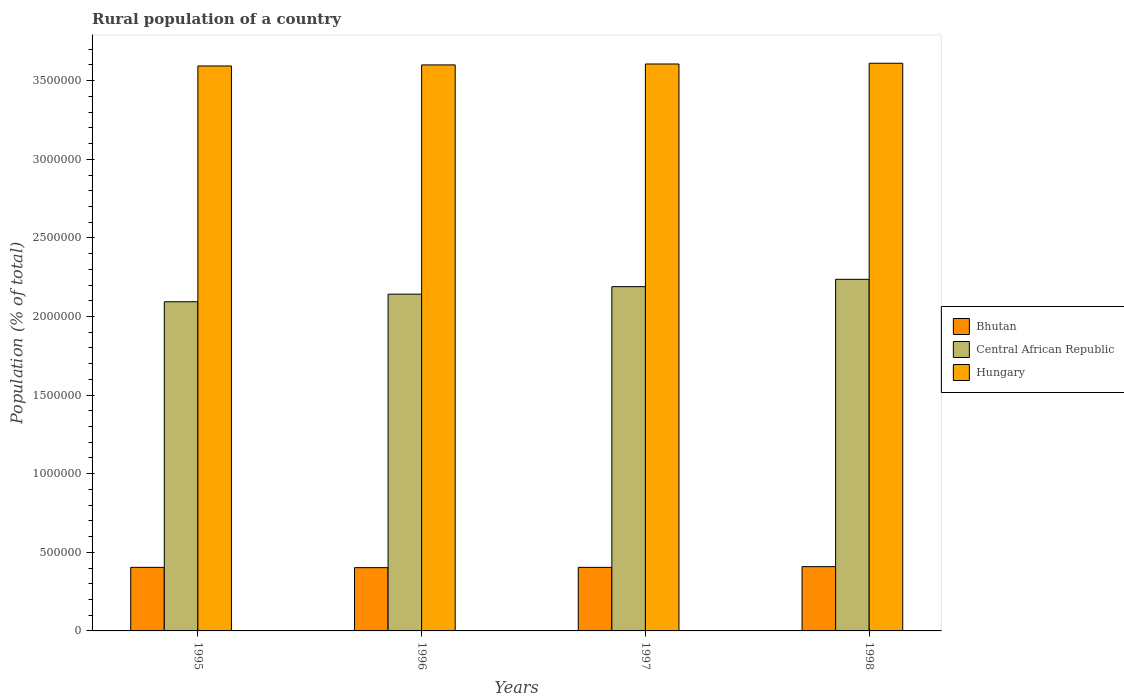How many bars are there on the 3rd tick from the left?
Provide a succinct answer. 3. How many bars are there on the 3rd tick from the right?
Offer a very short reply. 3. What is the label of the 3rd group of bars from the left?
Make the answer very short. 1997. In how many cases, is the number of bars for a given year not equal to the number of legend labels?
Give a very brief answer. 0. What is the rural population in Bhutan in 1997?
Your answer should be compact. 4.04e+05. Across all years, what is the maximum rural population in Hungary?
Your response must be concise. 3.61e+06. Across all years, what is the minimum rural population in Bhutan?
Offer a very short reply. 4.02e+05. In which year was the rural population in Central African Republic maximum?
Your answer should be very brief. 1998. In which year was the rural population in Hungary minimum?
Offer a terse response. 1995. What is the total rural population in Central African Republic in the graph?
Your answer should be compact. 8.66e+06. What is the difference between the rural population in Central African Republic in 1995 and that in 1998?
Keep it short and to the point. -1.43e+05. What is the difference between the rural population in Central African Republic in 1998 and the rural population in Bhutan in 1995?
Offer a terse response. 1.83e+06. What is the average rural population in Hungary per year?
Offer a very short reply. 3.60e+06. In the year 1998, what is the difference between the rural population in Hungary and rural population in Central African Republic?
Offer a very short reply. 1.37e+06. What is the ratio of the rural population in Bhutan in 1996 to that in 1997?
Give a very brief answer. 1. Is the rural population in Hungary in 1996 less than that in 1997?
Keep it short and to the point. Yes. What is the difference between the highest and the second highest rural population in Hungary?
Your response must be concise. 4657. What is the difference between the highest and the lowest rural population in Hungary?
Offer a very short reply. 1.73e+04. In how many years, is the rural population in Central African Republic greater than the average rural population in Central African Republic taken over all years?
Give a very brief answer. 2. Is the sum of the rural population in Hungary in 1995 and 1997 greater than the maximum rural population in Central African Republic across all years?
Make the answer very short. Yes. What does the 2nd bar from the left in 1996 represents?
Your answer should be compact. Central African Republic. What does the 2nd bar from the right in 1995 represents?
Offer a terse response. Central African Republic. How many bars are there?
Make the answer very short. 12. Are all the bars in the graph horizontal?
Offer a terse response. No. How many years are there in the graph?
Your response must be concise. 4. Does the graph contain any zero values?
Offer a very short reply. No. Does the graph contain grids?
Keep it short and to the point. No. How many legend labels are there?
Your response must be concise. 3. How are the legend labels stacked?
Your answer should be very brief. Vertical. What is the title of the graph?
Provide a short and direct response. Rural population of a country. What is the label or title of the Y-axis?
Make the answer very short. Population (% of total). What is the Population (% of total) of Bhutan in 1995?
Make the answer very short. 4.04e+05. What is the Population (% of total) in Central African Republic in 1995?
Your answer should be very brief. 2.09e+06. What is the Population (% of total) of Hungary in 1995?
Ensure brevity in your answer.  3.59e+06. What is the Population (% of total) in Bhutan in 1996?
Keep it short and to the point. 4.02e+05. What is the Population (% of total) in Central African Republic in 1996?
Ensure brevity in your answer.  2.14e+06. What is the Population (% of total) in Hungary in 1996?
Ensure brevity in your answer.  3.60e+06. What is the Population (% of total) in Bhutan in 1997?
Offer a very short reply. 4.04e+05. What is the Population (% of total) in Central African Republic in 1997?
Make the answer very short. 2.19e+06. What is the Population (% of total) of Hungary in 1997?
Offer a terse response. 3.61e+06. What is the Population (% of total) in Bhutan in 1998?
Offer a very short reply. 4.09e+05. What is the Population (% of total) of Central African Republic in 1998?
Offer a very short reply. 2.24e+06. What is the Population (% of total) in Hungary in 1998?
Make the answer very short. 3.61e+06. Across all years, what is the maximum Population (% of total) in Bhutan?
Provide a succinct answer. 4.09e+05. Across all years, what is the maximum Population (% of total) in Central African Republic?
Provide a short and direct response. 2.24e+06. Across all years, what is the maximum Population (% of total) of Hungary?
Your answer should be compact. 3.61e+06. Across all years, what is the minimum Population (% of total) in Bhutan?
Your answer should be very brief. 4.02e+05. Across all years, what is the minimum Population (% of total) of Central African Republic?
Offer a very short reply. 2.09e+06. Across all years, what is the minimum Population (% of total) of Hungary?
Your answer should be very brief. 3.59e+06. What is the total Population (% of total) in Bhutan in the graph?
Your answer should be very brief. 1.62e+06. What is the total Population (% of total) in Central African Republic in the graph?
Your response must be concise. 8.66e+06. What is the total Population (% of total) of Hungary in the graph?
Give a very brief answer. 1.44e+07. What is the difference between the Population (% of total) of Bhutan in 1995 and that in 1996?
Keep it short and to the point. 1944. What is the difference between the Population (% of total) in Central African Republic in 1995 and that in 1996?
Provide a short and direct response. -4.83e+04. What is the difference between the Population (% of total) in Hungary in 1995 and that in 1996?
Provide a succinct answer. -6825. What is the difference between the Population (% of total) in Bhutan in 1995 and that in 1997?
Provide a succinct answer. 159. What is the difference between the Population (% of total) of Central African Republic in 1995 and that in 1997?
Give a very brief answer. -9.60e+04. What is the difference between the Population (% of total) of Hungary in 1995 and that in 1997?
Your response must be concise. -1.26e+04. What is the difference between the Population (% of total) in Bhutan in 1995 and that in 1998?
Make the answer very short. -4403. What is the difference between the Population (% of total) of Central African Republic in 1995 and that in 1998?
Your answer should be very brief. -1.43e+05. What is the difference between the Population (% of total) of Hungary in 1995 and that in 1998?
Your answer should be compact. -1.73e+04. What is the difference between the Population (% of total) in Bhutan in 1996 and that in 1997?
Ensure brevity in your answer.  -1785. What is the difference between the Population (% of total) of Central African Republic in 1996 and that in 1997?
Offer a very short reply. -4.78e+04. What is the difference between the Population (% of total) of Hungary in 1996 and that in 1997?
Your answer should be compact. -5823. What is the difference between the Population (% of total) of Bhutan in 1996 and that in 1998?
Your answer should be very brief. -6347. What is the difference between the Population (% of total) of Central African Republic in 1996 and that in 1998?
Ensure brevity in your answer.  -9.44e+04. What is the difference between the Population (% of total) of Hungary in 1996 and that in 1998?
Provide a succinct answer. -1.05e+04. What is the difference between the Population (% of total) of Bhutan in 1997 and that in 1998?
Make the answer very short. -4562. What is the difference between the Population (% of total) of Central African Republic in 1997 and that in 1998?
Your response must be concise. -4.66e+04. What is the difference between the Population (% of total) of Hungary in 1997 and that in 1998?
Your answer should be compact. -4657. What is the difference between the Population (% of total) of Bhutan in 1995 and the Population (% of total) of Central African Republic in 1996?
Provide a succinct answer. -1.74e+06. What is the difference between the Population (% of total) of Bhutan in 1995 and the Population (% of total) of Hungary in 1996?
Provide a succinct answer. -3.20e+06. What is the difference between the Population (% of total) of Central African Republic in 1995 and the Population (% of total) of Hungary in 1996?
Your response must be concise. -1.51e+06. What is the difference between the Population (% of total) of Bhutan in 1995 and the Population (% of total) of Central African Republic in 1997?
Offer a very short reply. -1.79e+06. What is the difference between the Population (% of total) in Bhutan in 1995 and the Population (% of total) in Hungary in 1997?
Offer a very short reply. -3.20e+06. What is the difference between the Population (% of total) in Central African Republic in 1995 and the Population (% of total) in Hungary in 1997?
Offer a terse response. -1.51e+06. What is the difference between the Population (% of total) of Bhutan in 1995 and the Population (% of total) of Central African Republic in 1998?
Offer a terse response. -1.83e+06. What is the difference between the Population (% of total) in Bhutan in 1995 and the Population (% of total) in Hungary in 1998?
Make the answer very short. -3.21e+06. What is the difference between the Population (% of total) in Central African Republic in 1995 and the Population (% of total) in Hungary in 1998?
Ensure brevity in your answer.  -1.52e+06. What is the difference between the Population (% of total) of Bhutan in 1996 and the Population (% of total) of Central African Republic in 1997?
Offer a terse response. -1.79e+06. What is the difference between the Population (% of total) of Bhutan in 1996 and the Population (% of total) of Hungary in 1997?
Keep it short and to the point. -3.20e+06. What is the difference between the Population (% of total) of Central African Republic in 1996 and the Population (% of total) of Hungary in 1997?
Offer a terse response. -1.46e+06. What is the difference between the Population (% of total) in Bhutan in 1996 and the Population (% of total) in Central African Republic in 1998?
Offer a terse response. -1.83e+06. What is the difference between the Population (% of total) in Bhutan in 1996 and the Population (% of total) in Hungary in 1998?
Your response must be concise. -3.21e+06. What is the difference between the Population (% of total) of Central African Republic in 1996 and the Population (% of total) of Hungary in 1998?
Ensure brevity in your answer.  -1.47e+06. What is the difference between the Population (% of total) of Bhutan in 1997 and the Population (% of total) of Central African Republic in 1998?
Provide a succinct answer. -1.83e+06. What is the difference between the Population (% of total) in Bhutan in 1997 and the Population (% of total) in Hungary in 1998?
Your answer should be very brief. -3.21e+06. What is the difference between the Population (% of total) in Central African Republic in 1997 and the Population (% of total) in Hungary in 1998?
Your answer should be compact. -1.42e+06. What is the average Population (% of total) in Bhutan per year?
Your response must be concise. 4.05e+05. What is the average Population (% of total) in Central African Republic per year?
Your answer should be compact. 2.17e+06. What is the average Population (% of total) in Hungary per year?
Keep it short and to the point. 3.60e+06. In the year 1995, what is the difference between the Population (% of total) of Bhutan and Population (% of total) of Central African Republic?
Your answer should be very brief. -1.69e+06. In the year 1995, what is the difference between the Population (% of total) in Bhutan and Population (% of total) in Hungary?
Your response must be concise. -3.19e+06. In the year 1995, what is the difference between the Population (% of total) of Central African Republic and Population (% of total) of Hungary?
Offer a very short reply. -1.50e+06. In the year 1996, what is the difference between the Population (% of total) of Bhutan and Population (% of total) of Central African Republic?
Ensure brevity in your answer.  -1.74e+06. In the year 1996, what is the difference between the Population (% of total) in Bhutan and Population (% of total) in Hungary?
Keep it short and to the point. -3.20e+06. In the year 1996, what is the difference between the Population (% of total) of Central African Republic and Population (% of total) of Hungary?
Make the answer very short. -1.46e+06. In the year 1997, what is the difference between the Population (% of total) in Bhutan and Population (% of total) in Central African Republic?
Make the answer very short. -1.79e+06. In the year 1997, what is the difference between the Population (% of total) of Bhutan and Population (% of total) of Hungary?
Ensure brevity in your answer.  -3.20e+06. In the year 1997, what is the difference between the Population (% of total) of Central African Republic and Population (% of total) of Hungary?
Your response must be concise. -1.42e+06. In the year 1998, what is the difference between the Population (% of total) in Bhutan and Population (% of total) in Central African Republic?
Your answer should be very brief. -1.83e+06. In the year 1998, what is the difference between the Population (% of total) of Bhutan and Population (% of total) of Hungary?
Your answer should be very brief. -3.20e+06. In the year 1998, what is the difference between the Population (% of total) of Central African Republic and Population (% of total) of Hungary?
Provide a succinct answer. -1.37e+06. What is the ratio of the Population (% of total) of Bhutan in 1995 to that in 1996?
Give a very brief answer. 1. What is the ratio of the Population (% of total) of Central African Republic in 1995 to that in 1996?
Ensure brevity in your answer.  0.98. What is the ratio of the Population (% of total) in Hungary in 1995 to that in 1996?
Offer a terse response. 1. What is the ratio of the Population (% of total) of Bhutan in 1995 to that in 1997?
Offer a very short reply. 1. What is the ratio of the Population (% of total) of Central African Republic in 1995 to that in 1997?
Offer a terse response. 0.96. What is the ratio of the Population (% of total) of Hungary in 1995 to that in 1997?
Your response must be concise. 1. What is the ratio of the Population (% of total) of Central African Republic in 1995 to that in 1998?
Provide a short and direct response. 0.94. What is the ratio of the Population (% of total) of Hungary in 1995 to that in 1998?
Your response must be concise. 1. What is the ratio of the Population (% of total) in Bhutan in 1996 to that in 1997?
Ensure brevity in your answer.  1. What is the ratio of the Population (% of total) of Central African Republic in 1996 to that in 1997?
Your answer should be compact. 0.98. What is the ratio of the Population (% of total) of Hungary in 1996 to that in 1997?
Keep it short and to the point. 1. What is the ratio of the Population (% of total) of Bhutan in 1996 to that in 1998?
Offer a terse response. 0.98. What is the ratio of the Population (% of total) in Central African Republic in 1996 to that in 1998?
Offer a terse response. 0.96. What is the ratio of the Population (% of total) of Hungary in 1996 to that in 1998?
Your answer should be compact. 1. What is the ratio of the Population (% of total) of Central African Republic in 1997 to that in 1998?
Your answer should be compact. 0.98. What is the difference between the highest and the second highest Population (% of total) in Bhutan?
Your response must be concise. 4403. What is the difference between the highest and the second highest Population (% of total) of Central African Republic?
Your answer should be compact. 4.66e+04. What is the difference between the highest and the second highest Population (% of total) of Hungary?
Your answer should be very brief. 4657. What is the difference between the highest and the lowest Population (% of total) of Bhutan?
Your answer should be compact. 6347. What is the difference between the highest and the lowest Population (% of total) in Central African Republic?
Provide a short and direct response. 1.43e+05. What is the difference between the highest and the lowest Population (% of total) of Hungary?
Ensure brevity in your answer.  1.73e+04. 